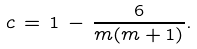Convert formula to latex. <formula><loc_0><loc_0><loc_500><loc_500>c \, = \, 1 \, - \, \frac { 6 } { m ( m + 1 ) } .</formula> 